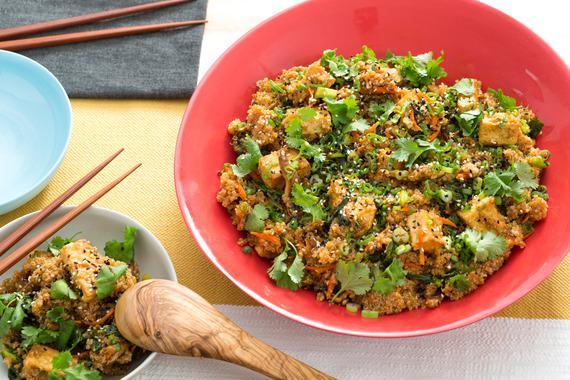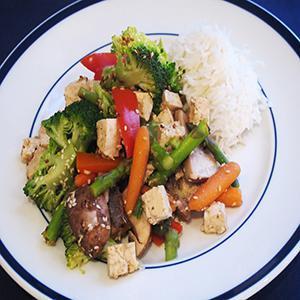The first image is the image on the left, the second image is the image on the right. Evaluate the accuracy of this statement regarding the images: "There is rice in the image on the right.". Is it true? Answer yes or no. Yes. The first image is the image on the left, the second image is the image on the right. Given the left and right images, does the statement "At least one image shows a broccoli dish served on an all white plate, with no colored trim." hold true? Answer yes or no. No. 